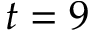<formula> <loc_0><loc_0><loc_500><loc_500>t = 9</formula> 